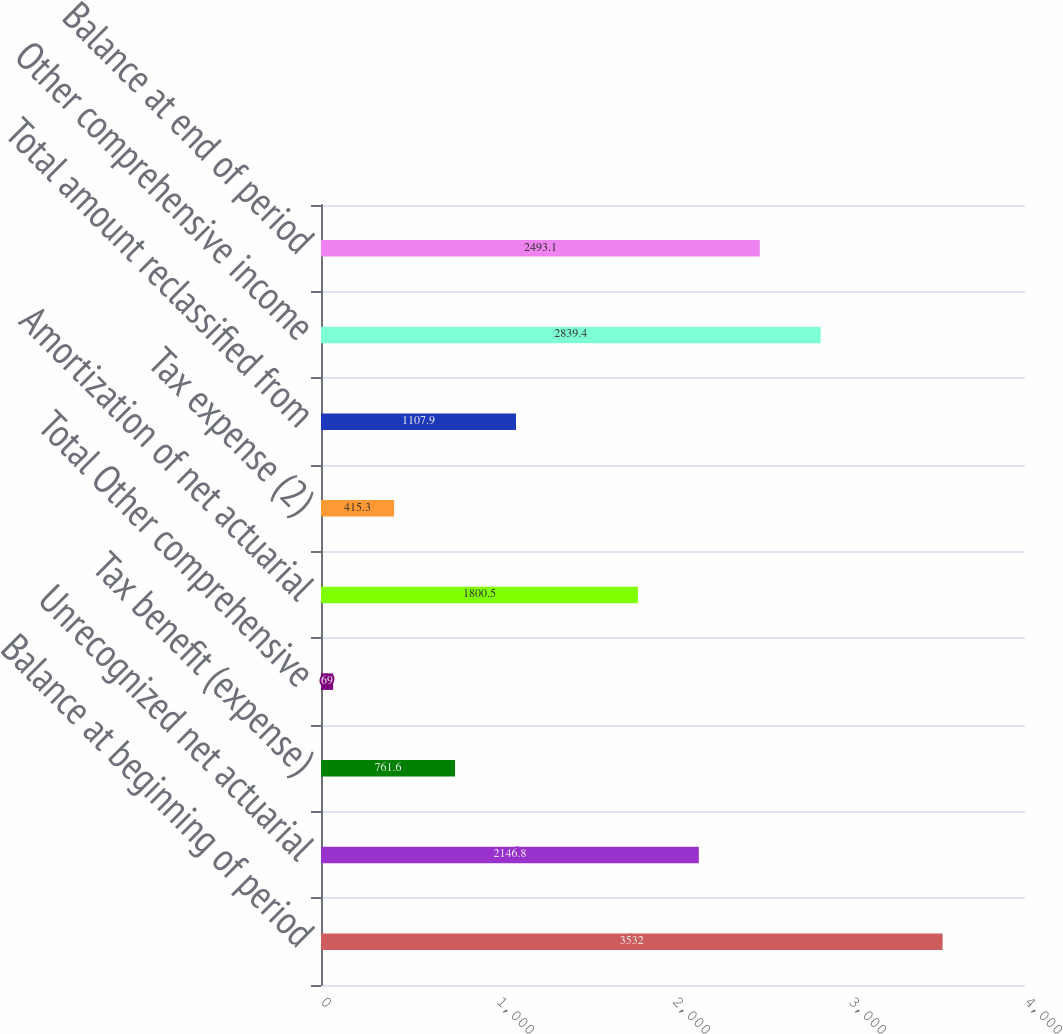Convert chart to OTSL. <chart><loc_0><loc_0><loc_500><loc_500><bar_chart><fcel>Balance at beginning of period<fcel>Unrecognized net actuarial<fcel>Tax benefit (expense)<fcel>Total Other comprehensive<fcel>Amortization of net actuarial<fcel>Tax expense (2)<fcel>Total amount reclassified from<fcel>Other comprehensive income<fcel>Balance at end of period<nl><fcel>3532<fcel>2146.8<fcel>761.6<fcel>69<fcel>1800.5<fcel>415.3<fcel>1107.9<fcel>2839.4<fcel>2493.1<nl></chart> 